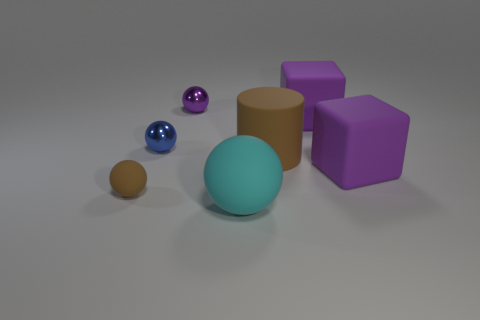The rubber sphere that is the same color as the big cylinder is what size?
Your response must be concise. Small. There is a large matte object that is the same color as the tiny matte object; what shape is it?
Ensure brevity in your answer.  Cylinder. Is there any other thing that is the same color as the small rubber ball?
Keep it short and to the point. Yes. Is the cylinder the same color as the small matte object?
Keep it short and to the point. Yes. Do the small thing in front of the rubber cylinder and the cylinder have the same color?
Offer a very short reply. Yes. What is the material of the purple thing that is to the left of the big rubber object in front of the tiny ball in front of the blue metal ball?
Ensure brevity in your answer.  Metal. What material is the small purple thing?
Keep it short and to the point. Metal. How many tiny rubber balls have the same color as the cylinder?
Your answer should be very brief. 1. The other rubber object that is the same shape as the small brown rubber thing is what color?
Your response must be concise. Cyan. What material is the object that is to the left of the big ball and in front of the small blue thing?
Provide a succinct answer. Rubber. 